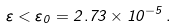Convert formula to latex. <formula><loc_0><loc_0><loc_500><loc_500>\varepsilon < \varepsilon _ { 0 } = 2 . 7 3 \times 1 0 ^ { - 5 } \, .</formula> 